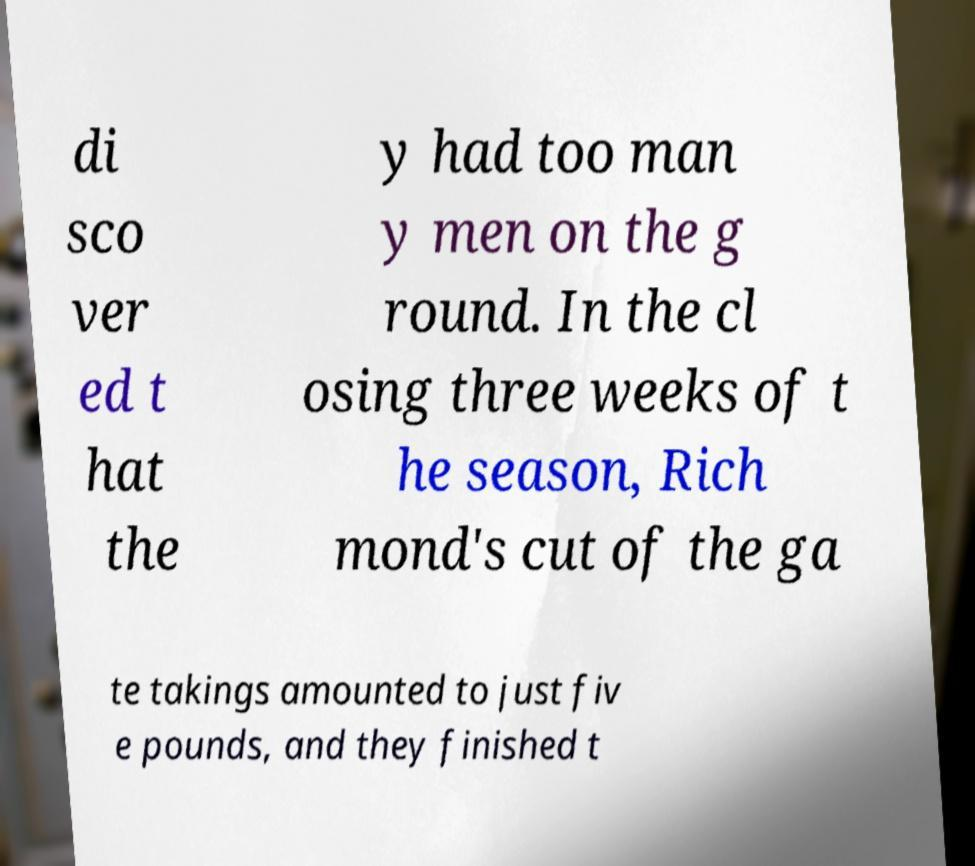What messages or text are displayed in this image? I need them in a readable, typed format. di sco ver ed t hat the y had too man y men on the g round. In the cl osing three weeks of t he season, Rich mond's cut of the ga te takings amounted to just fiv e pounds, and they finished t 